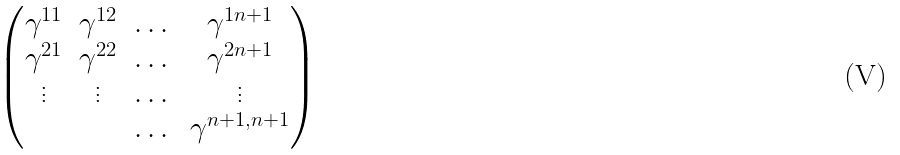<formula> <loc_0><loc_0><loc_500><loc_500>\begin{pmatrix} \gamma ^ { 1 1 } & \gamma ^ { 1 2 } & \dots & \gamma ^ { 1 n + 1 } \\ \gamma ^ { 2 1 } & \gamma ^ { 2 2 } & \dots & \gamma ^ { 2 n + 1 } \\ \vdots & \vdots & \dots & \vdots \\ & & \dots & \gamma ^ { n + 1 , n + 1 } \end{pmatrix}</formula> 